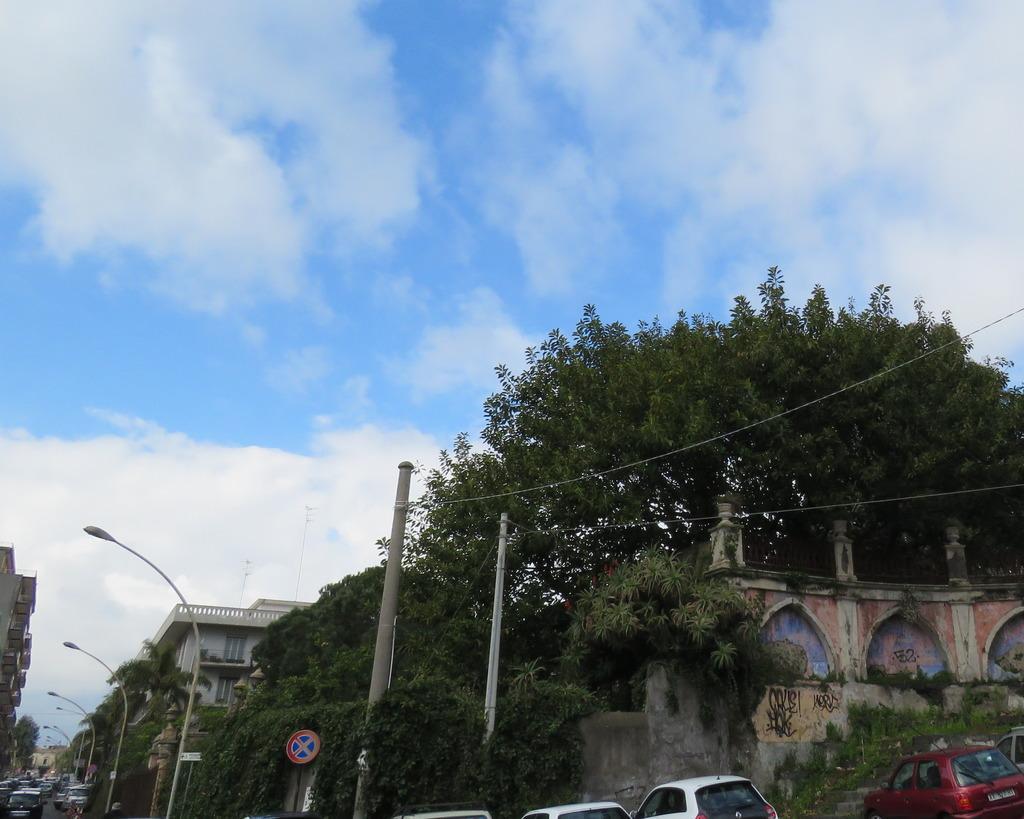In one or two sentences, can you explain what this image depicts? In this image, we can see trees, buildings, street lights, sign board, poles, walls, pillars, trees, plants and grass. At the bottom, we can see few vehicles. Background there is a cloudy sky. 